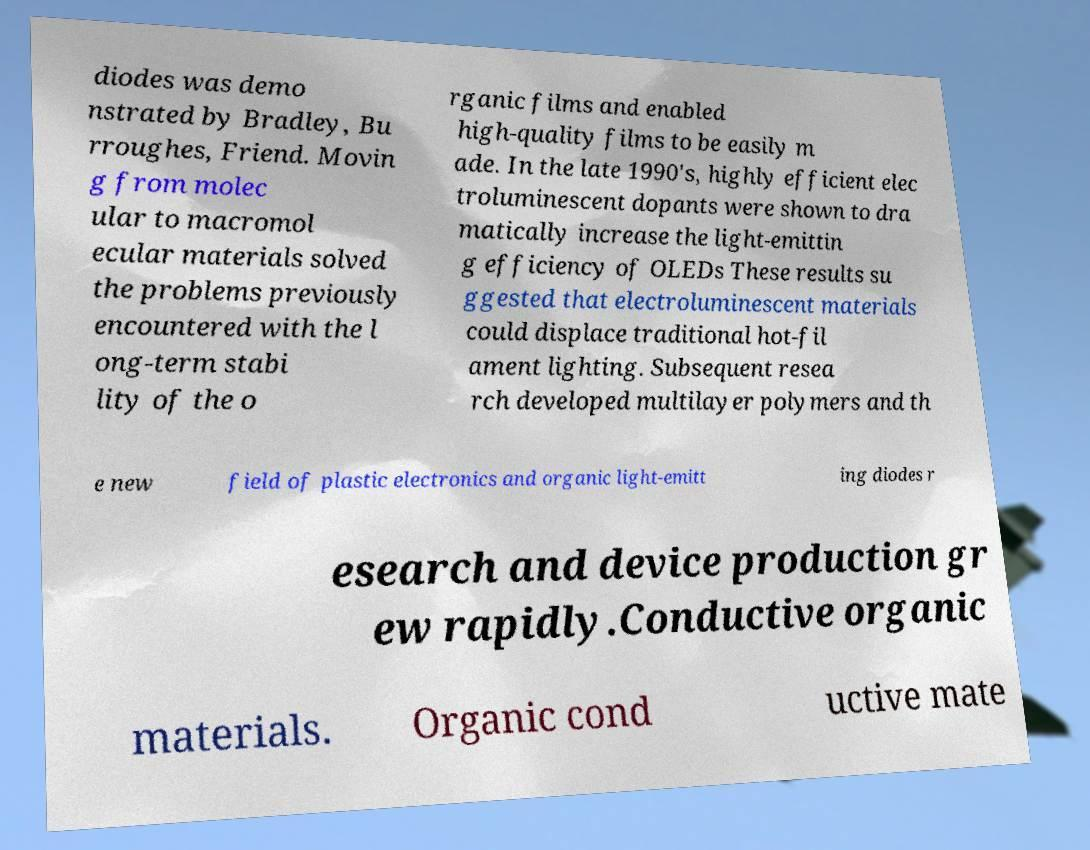Please read and relay the text visible in this image. What does it say? diodes was demo nstrated by Bradley, Bu rroughes, Friend. Movin g from molec ular to macromol ecular materials solved the problems previously encountered with the l ong-term stabi lity of the o rganic films and enabled high-quality films to be easily m ade. In the late 1990's, highly efficient elec troluminescent dopants were shown to dra matically increase the light-emittin g efficiency of OLEDs These results su ggested that electroluminescent materials could displace traditional hot-fil ament lighting. Subsequent resea rch developed multilayer polymers and th e new field of plastic electronics and organic light-emitt ing diodes r esearch and device production gr ew rapidly.Conductive organic materials. Organic cond uctive mate 